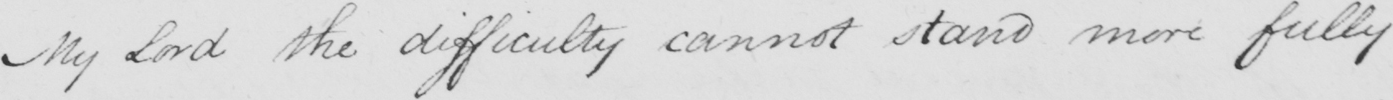Please provide the text content of this handwritten line. My Lord the difficulty cannot stand more fully 